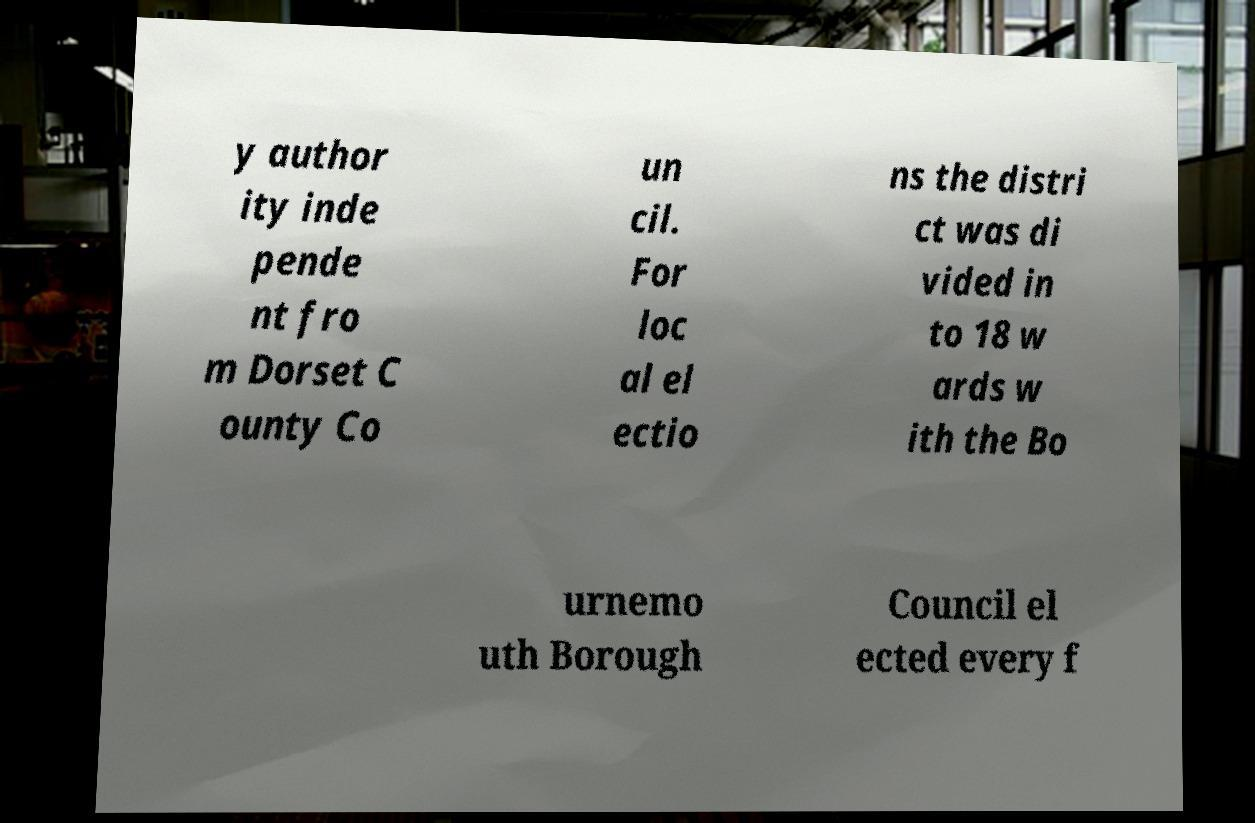What messages or text are displayed in this image? I need them in a readable, typed format. y author ity inde pende nt fro m Dorset C ounty Co un cil. For loc al el ectio ns the distri ct was di vided in to 18 w ards w ith the Bo urnemo uth Borough Council el ected every f 